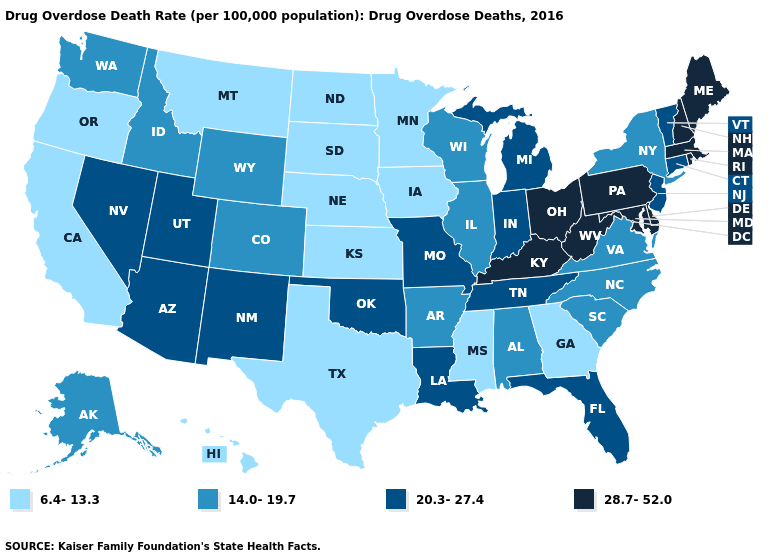What is the value of Tennessee?
Quick response, please. 20.3-27.4. Which states have the highest value in the USA?
Concise answer only. Delaware, Kentucky, Maine, Maryland, Massachusetts, New Hampshire, Ohio, Pennsylvania, Rhode Island, West Virginia. What is the lowest value in the MidWest?
Be succinct. 6.4-13.3. Does Arizona have a higher value than Idaho?
Write a very short answer. Yes. What is the highest value in states that border Illinois?
Be succinct. 28.7-52.0. Which states have the lowest value in the USA?
Short answer required. California, Georgia, Hawaii, Iowa, Kansas, Minnesota, Mississippi, Montana, Nebraska, North Dakota, Oregon, South Dakota, Texas. Does the map have missing data?
Answer briefly. No. What is the value of Oregon?
Answer briefly. 6.4-13.3. Name the states that have a value in the range 6.4-13.3?
Give a very brief answer. California, Georgia, Hawaii, Iowa, Kansas, Minnesota, Mississippi, Montana, Nebraska, North Dakota, Oregon, South Dakota, Texas. Does the map have missing data?
Be succinct. No. Does Colorado have the highest value in the USA?
Short answer required. No. What is the value of West Virginia?
Keep it brief. 28.7-52.0. Does Iowa have a higher value than Michigan?
Concise answer only. No. What is the value of New Mexico?
Keep it brief. 20.3-27.4. Name the states that have a value in the range 20.3-27.4?
Concise answer only. Arizona, Connecticut, Florida, Indiana, Louisiana, Michigan, Missouri, Nevada, New Jersey, New Mexico, Oklahoma, Tennessee, Utah, Vermont. 